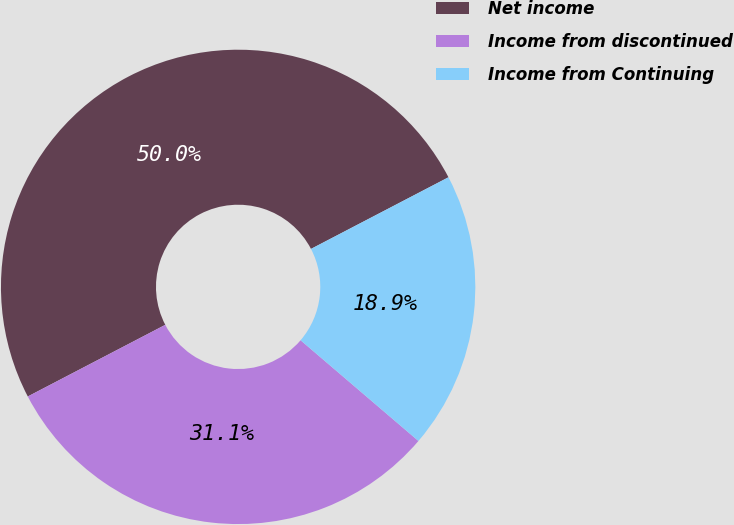<chart> <loc_0><loc_0><loc_500><loc_500><pie_chart><fcel>Net income<fcel>Income from discontinued<fcel>Income from Continuing<nl><fcel>50.0%<fcel>31.1%<fcel>18.9%<nl></chart> 